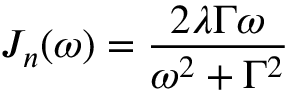Convert formula to latex. <formula><loc_0><loc_0><loc_500><loc_500>J _ { n } ( \omega ) = \frac { 2 \lambda \Gamma \omega } { \omega ^ { 2 } + \Gamma ^ { 2 } }</formula> 